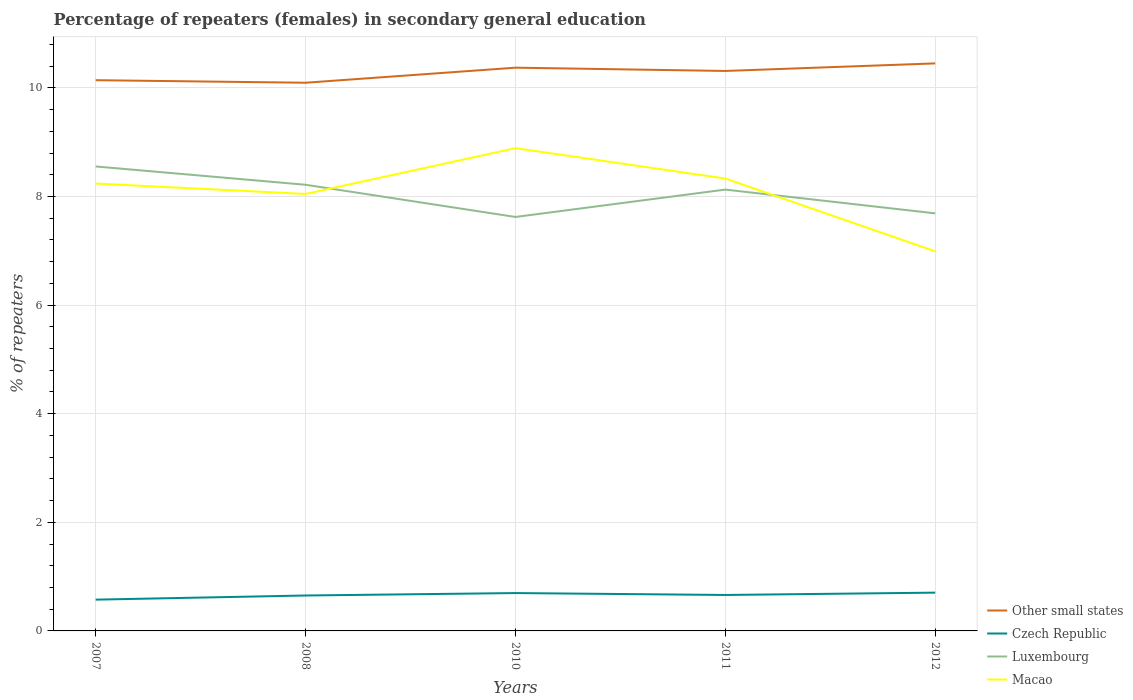Does the line corresponding to Luxembourg intersect with the line corresponding to Macao?
Offer a terse response. Yes. Across all years, what is the maximum percentage of female repeaters in Other small states?
Your answer should be compact. 10.09. In which year was the percentage of female repeaters in Macao maximum?
Keep it short and to the point. 2012. What is the total percentage of female repeaters in Macao in the graph?
Provide a succinct answer. -0.65. What is the difference between the highest and the second highest percentage of female repeaters in Other small states?
Provide a short and direct response. 0.36. What is the difference between the highest and the lowest percentage of female repeaters in Macao?
Your response must be concise. 3. How many lines are there?
Offer a very short reply. 4. How many years are there in the graph?
Your answer should be very brief. 5. Are the values on the major ticks of Y-axis written in scientific E-notation?
Provide a short and direct response. No. Does the graph contain any zero values?
Your answer should be compact. No. What is the title of the graph?
Offer a very short reply. Percentage of repeaters (females) in secondary general education. What is the label or title of the X-axis?
Make the answer very short. Years. What is the label or title of the Y-axis?
Ensure brevity in your answer.  % of repeaters. What is the % of repeaters in Other small states in 2007?
Ensure brevity in your answer.  10.14. What is the % of repeaters of Czech Republic in 2007?
Provide a succinct answer. 0.58. What is the % of repeaters of Luxembourg in 2007?
Offer a terse response. 8.55. What is the % of repeaters in Macao in 2007?
Ensure brevity in your answer.  8.24. What is the % of repeaters of Other small states in 2008?
Your answer should be very brief. 10.09. What is the % of repeaters in Czech Republic in 2008?
Give a very brief answer. 0.65. What is the % of repeaters of Luxembourg in 2008?
Keep it short and to the point. 8.22. What is the % of repeaters in Macao in 2008?
Your answer should be very brief. 8.05. What is the % of repeaters in Other small states in 2010?
Provide a short and direct response. 10.37. What is the % of repeaters of Czech Republic in 2010?
Ensure brevity in your answer.  0.7. What is the % of repeaters of Luxembourg in 2010?
Provide a succinct answer. 7.62. What is the % of repeaters in Macao in 2010?
Your response must be concise. 8.89. What is the % of repeaters of Other small states in 2011?
Your answer should be very brief. 10.31. What is the % of repeaters of Czech Republic in 2011?
Make the answer very short. 0.66. What is the % of repeaters of Luxembourg in 2011?
Provide a succinct answer. 8.13. What is the % of repeaters of Macao in 2011?
Your answer should be very brief. 8.33. What is the % of repeaters of Other small states in 2012?
Provide a succinct answer. 10.45. What is the % of repeaters in Czech Republic in 2012?
Ensure brevity in your answer.  0.7. What is the % of repeaters of Luxembourg in 2012?
Your answer should be very brief. 7.69. What is the % of repeaters of Macao in 2012?
Provide a succinct answer. 6.99. Across all years, what is the maximum % of repeaters in Other small states?
Provide a succinct answer. 10.45. Across all years, what is the maximum % of repeaters of Czech Republic?
Your answer should be compact. 0.7. Across all years, what is the maximum % of repeaters in Luxembourg?
Your answer should be very brief. 8.55. Across all years, what is the maximum % of repeaters of Macao?
Your response must be concise. 8.89. Across all years, what is the minimum % of repeaters of Other small states?
Provide a short and direct response. 10.09. Across all years, what is the minimum % of repeaters of Czech Republic?
Your response must be concise. 0.58. Across all years, what is the minimum % of repeaters of Luxembourg?
Provide a short and direct response. 7.62. Across all years, what is the minimum % of repeaters of Macao?
Your answer should be compact. 6.99. What is the total % of repeaters of Other small states in the graph?
Give a very brief answer. 51.37. What is the total % of repeaters of Czech Republic in the graph?
Your response must be concise. 3.29. What is the total % of repeaters of Luxembourg in the graph?
Ensure brevity in your answer.  40.21. What is the total % of repeaters in Macao in the graph?
Offer a terse response. 40.49. What is the difference between the % of repeaters in Other small states in 2007 and that in 2008?
Offer a very short reply. 0.05. What is the difference between the % of repeaters of Czech Republic in 2007 and that in 2008?
Provide a short and direct response. -0.08. What is the difference between the % of repeaters in Luxembourg in 2007 and that in 2008?
Your answer should be compact. 0.34. What is the difference between the % of repeaters in Macao in 2007 and that in 2008?
Keep it short and to the point. 0.19. What is the difference between the % of repeaters of Other small states in 2007 and that in 2010?
Offer a terse response. -0.23. What is the difference between the % of repeaters in Czech Republic in 2007 and that in 2010?
Your answer should be very brief. -0.12. What is the difference between the % of repeaters of Luxembourg in 2007 and that in 2010?
Keep it short and to the point. 0.93. What is the difference between the % of repeaters in Macao in 2007 and that in 2010?
Offer a terse response. -0.65. What is the difference between the % of repeaters of Other small states in 2007 and that in 2011?
Your response must be concise. -0.17. What is the difference between the % of repeaters of Czech Republic in 2007 and that in 2011?
Offer a very short reply. -0.09. What is the difference between the % of repeaters of Luxembourg in 2007 and that in 2011?
Provide a short and direct response. 0.43. What is the difference between the % of repeaters of Macao in 2007 and that in 2011?
Offer a very short reply. -0.09. What is the difference between the % of repeaters in Other small states in 2007 and that in 2012?
Your answer should be compact. -0.31. What is the difference between the % of repeaters of Czech Republic in 2007 and that in 2012?
Your answer should be compact. -0.13. What is the difference between the % of repeaters in Luxembourg in 2007 and that in 2012?
Provide a succinct answer. 0.86. What is the difference between the % of repeaters of Macao in 2007 and that in 2012?
Provide a succinct answer. 1.25. What is the difference between the % of repeaters of Other small states in 2008 and that in 2010?
Ensure brevity in your answer.  -0.28. What is the difference between the % of repeaters in Czech Republic in 2008 and that in 2010?
Your answer should be very brief. -0.04. What is the difference between the % of repeaters in Luxembourg in 2008 and that in 2010?
Keep it short and to the point. 0.59. What is the difference between the % of repeaters of Macao in 2008 and that in 2010?
Provide a succinct answer. -0.84. What is the difference between the % of repeaters of Other small states in 2008 and that in 2011?
Keep it short and to the point. -0.22. What is the difference between the % of repeaters in Czech Republic in 2008 and that in 2011?
Your answer should be compact. -0.01. What is the difference between the % of repeaters in Luxembourg in 2008 and that in 2011?
Give a very brief answer. 0.09. What is the difference between the % of repeaters of Macao in 2008 and that in 2011?
Provide a short and direct response. -0.28. What is the difference between the % of repeaters of Other small states in 2008 and that in 2012?
Your answer should be very brief. -0.36. What is the difference between the % of repeaters in Czech Republic in 2008 and that in 2012?
Provide a short and direct response. -0.05. What is the difference between the % of repeaters of Luxembourg in 2008 and that in 2012?
Keep it short and to the point. 0.53. What is the difference between the % of repeaters in Macao in 2008 and that in 2012?
Offer a terse response. 1.06. What is the difference between the % of repeaters in Other small states in 2010 and that in 2011?
Offer a very short reply. 0.06. What is the difference between the % of repeaters of Czech Republic in 2010 and that in 2011?
Offer a very short reply. 0.04. What is the difference between the % of repeaters of Luxembourg in 2010 and that in 2011?
Offer a very short reply. -0.5. What is the difference between the % of repeaters in Macao in 2010 and that in 2011?
Your answer should be very brief. 0.56. What is the difference between the % of repeaters of Other small states in 2010 and that in 2012?
Offer a very short reply. -0.08. What is the difference between the % of repeaters of Czech Republic in 2010 and that in 2012?
Provide a succinct answer. -0.01. What is the difference between the % of repeaters in Luxembourg in 2010 and that in 2012?
Give a very brief answer. -0.07. What is the difference between the % of repeaters in Macao in 2010 and that in 2012?
Provide a short and direct response. 1.9. What is the difference between the % of repeaters of Other small states in 2011 and that in 2012?
Provide a short and direct response. -0.14. What is the difference between the % of repeaters of Czech Republic in 2011 and that in 2012?
Your answer should be very brief. -0.04. What is the difference between the % of repeaters of Luxembourg in 2011 and that in 2012?
Your response must be concise. 0.44. What is the difference between the % of repeaters of Macao in 2011 and that in 2012?
Ensure brevity in your answer.  1.34. What is the difference between the % of repeaters in Other small states in 2007 and the % of repeaters in Czech Republic in 2008?
Keep it short and to the point. 9.49. What is the difference between the % of repeaters of Other small states in 2007 and the % of repeaters of Luxembourg in 2008?
Provide a short and direct response. 1.93. What is the difference between the % of repeaters in Other small states in 2007 and the % of repeaters in Macao in 2008?
Provide a short and direct response. 2.09. What is the difference between the % of repeaters of Czech Republic in 2007 and the % of repeaters of Luxembourg in 2008?
Your response must be concise. -7.64. What is the difference between the % of repeaters of Czech Republic in 2007 and the % of repeaters of Macao in 2008?
Offer a terse response. -7.47. What is the difference between the % of repeaters of Luxembourg in 2007 and the % of repeaters of Macao in 2008?
Offer a terse response. 0.51. What is the difference between the % of repeaters of Other small states in 2007 and the % of repeaters of Czech Republic in 2010?
Offer a very short reply. 9.44. What is the difference between the % of repeaters of Other small states in 2007 and the % of repeaters of Luxembourg in 2010?
Provide a short and direct response. 2.52. What is the difference between the % of repeaters in Other small states in 2007 and the % of repeaters in Macao in 2010?
Your answer should be compact. 1.25. What is the difference between the % of repeaters of Czech Republic in 2007 and the % of repeaters of Luxembourg in 2010?
Give a very brief answer. -7.05. What is the difference between the % of repeaters in Czech Republic in 2007 and the % of repeaters in Macao in 2010?
Keep it short and to the point. -8.31. What is the difference between the % of repeaters of Luxembourg in 2007 and the % of repeaters of Macao in 2010?
Provide a succinct answer. -0.34. What is the difference between the % of repeaters of Other small states in 2007 and the % of repeaters of Czech Republic in 2011?
Keep it short and to the point. 9.48. What is the difference between the % of repeaters of Other small states in 2007 and the % of repeaters of Luxembourg in 2011?
Ensure brevity in your answer.  2.01. What is the difference between the % of repeaters of Other small states in 2007 and the % of repeaters of Macao in 2011?
Make the answer very short. 1.81. What is the difference between the % of repeaters of Czech Republic in 2007 and the % of repeaters of Luxembourg in 2011?
Offer a terse response. -7.55. What is the difference between the % of repeaters of Czech Republic in 2007 and the % of repeaters of Macao in 2011?
Your answer should be compact. -7.75. What is the difference between the % of repeaters in Luxembourg in 2007 and the % of repeaters in Macao in 2011?
Keep it short and to the point. 0.22. What is the difference between the % of repeaters in Other small states in 2007 and the % of repeaters in Czech Republic in 2012?
Provide a short and direct response. 9.44. What is the difference between the % of repeaters in Other small states in 2007 and the % of repeaters in Luxembourg in 2012?
Give a very brief answer. 2.45. What is the difference between the % of repeaters of Other small states in 2007 and the % of repeaters of Macao in 2012?
Give a very brief answer. 3.15. What is the difference between the % of repeaters in Czech Republic in 2007 and the % of repeaters in Luxembourg in 2012?
Your response must be concise. -7.11. What is the difference between the % of repeaters of Czech Republic in 2007 and the % of repeaters of Macao in 2012?
Your response must be concise. -6.41. What is the difference between the % of repeaters of Luxembourg in 2007 and the % of repeaters of Macao in 2012?
Ensure brevity in your answer.  1.56. What is the difference between the % of repeaters in Other small states in 2008 and the % of repeaters in Czech Republic in 2010?
Ensure brevity in your answer.  9.4. What is the difference between the % of repeaters in Other small states in 2008 and the % of repeaters in Luxembourg in 2010?
Ensure brevity in your answer.  2.47. What is the difference between the % of repeaters of Other small states in 2008 and the % of repeaters of Macao in 2010?
Keep it short and to the point. 1.2. What is the difference between the % of repeaters in Czech Republic in 2008 and the % of repeaters in Luxembourg in 2010?
Offer a very short reply. -6.97. What is the difference between the % of repeaters of Czech Republic in 2008 and the % of repeaters of Macao in 2010?
Give a very brief answer. -8.24. What is the difference between the % of repeaters in Luxembourg in 2008 and the % of repeaters in Macao in 2010?
Your response must be concise. -0.67. What is the difference between the % of repeaters in Other small states in 2008 and the % of repeaters in Czech Republic in 2011?
Your answer should be very brief. 9.43. What is the difference between the % of repeaters in Other small states in 2008 and the % of repeaters in Luxembourg in 2011?
Provide a succinct answer. 1.97. What is the difference between the % of repeaters in Other small states in 2008 and the % of repeaters in Macao in 2011?
Offer a terse response. 1.76. What is the difference between the % of repeaters of Czech Republic in 2008 and the % of repeaters of Luxembourg in 2011?
Provide a succinct answer. -7.47. What is the difference between the % of repeaters of Czech Republic in 2008 and the % of repeaters of Macao in 2011?
Offer a terse response. -7.68. What is the difference between the % of repeaters in Luxembourg in 2008 and the % of repeaters in Macao in 2011?
Your answer should be very brief. -0.12. What is the difference between the % of repeaters in Other small states in 2008 and the % of repeaters in Czech Republic in 2012?
Make the answer very short. 9.39. What is the difference between the % of repeaters in Other small states in 2008 and the % of repeaters in Luxembourg in 2012?
Keep it short and to the point. 2.41. What is the difference between the % of repeaters of Other small states in 2008 and the % of repeaters of Macao in 2012?
Offer a very short reply. 3.1. What is the difference between the % of repeaters in Czech Republic in 2008 and the % of repeaters in Luxembourg in 2012?
Ensure brevity in your answer.  -7.04. What is the difference between the % of repeaters in Czech Republic in 2008 and the % of repeaters in Macao in 2012?
Make the answer very short. -6.34. What is the difference between the % of repeaters in Luxembourg in 2008 and the % of repeaters in Macao in 2012?
Your answer should be very brief. 1.23. What is the difference between the % of repeaters in Other small states in 2010 and the % of repeaters in Czech Republic in 2011?
Provide a short and direct response. 9.71. What is the difference between the % of repeaters in Other small states in 2010 and the % of repeaters in Luxembourg in 2011?
Keep it short and to the point. 2.24. What is the difference between the % of repeaters of Other small states in 2010 and the % of repeaters of Macao in 2011?
Your answer should be compact. 2.04. What is the difference between the % of repeaters in Czech Republic in 2010 and the % of repeaters in Luxembourg in 2011?
Offer a very short reply. -7.43. What is the difference between the % of repeaters of Czech Republic in 2010 and the % of repeaters of Macao in 2011?
Keep it short and to the point. -7.63. What is the difference between the % of repeaters in Luxembourg in 2010 and the % of repeaters in Macao in 2011?
Give a very brief answer. -0.71. What is the difference between the % of repeaters of Other small states in 2010 and the % of repeaters of Czech Republic in 2012?
Give a very brief answer. 9.67. What is the difference between the % of repeaters in Other small states in 2010 and the % of repeaters in Luxembourg in 2012?
Offer a very short reply. 2.68. What is the difference between the % of repeaters in Other small states in 2010 and the % of repeaters in Macao in 2012?
Make the answer very short. 3.38. What is the difference between the % of repeaters of Czech Republic in 2010 and the % of repeaters of Luxembourg in 2012?
Your answer should be very brief. -6.99. What is the difference between the % of repeaters in Czech Republic in 2010 and the % of repeaters in Macao in 2012?
Provide a succinct answer. -6.29. What is the difference between the % of repeaters of Luxembourg in 2010 and the % of repeaters of Macao in 2012?
Offer a terse response. 0.63. What is the difference between the % of repeaters in Other small states in 2011 and the % of repeaters in Czech Republic in 2012?
Provide a succinct answer. 9.61. What is the difference between the % of repeaters in Other small states in 2011 and the % of repeaters in Luxembourg in 2012?
Your answer should be compact. 2.62. What is the difference between the % of repeaters of Other small states in 2011 and the % of repeaters of Macao in 2012?
Provide a short and direct response. 3.32. What is the difference between the % of repeaters in Czech Republic in 2011 and the % of repeaters in Luxembourg in 2012?
Make the answer very short. -7.03. What is the difference between the % of repeaters of Czech Republic in 2011 and the % of repeaters of Macao in 2012?
Give a very brief answer. -6.33. What is the difference between the % of repeaters of Luxembourg in 2011 and the % of repeaters of Macao in 2012?
Your answer should be compact. 1.14. What is the average % of repeaters of Other small states per year?
Offer a terse response. 10.27. What is the average % of repeaters in Czech Republic per year?
Your answer should be very brief. 0.66. What is the average % of repeaters in Luxembourg per year?
Your answer should be very brief. 8.04. What is the average % of repeaters of Macao per year?
Your response must be concise. 8.1. In the year 2007, what is the difference between the % of repeaters of Other small states and % of repeaters of Czech Republic?
Give a very brief answer. 9.56. In the year 2007, what is the difference between the % of repeaters in Other small states and % of repeaters in Luxembourg?
Offer a terse response. 1.59. In the year 2007, what is the difference between the % of repeaters in Other small states and % of repeaters in Macao?
Your response must be concise. 1.9. In the year 2007, what is the difference between the % of repeaters of Czech Republic and % of repeaters of Luxembourg?
Ensure brevity in your answer.  -7.98. In the year 2007, what is the difference between the % of repeaters of Czech Republic and % of repeaters of Macao?
Provide a short and direct response. -7.66. In the year 2007, what is the difference between the % of repeaters of Luxembourg and % of repeaters of Macao?
Give a very brief answer. 0.31. In the year 2008, what is the difference between the % of repeaters in Other small states and % of repeaters in Czech Republic?
Give a very brief answer. 9.44. In the year 2008, what is the difference between the % of repeaters of Other small states and % of repeaters of Luxembourg?
Your answer should be very brief. 1.88. In the year 2008, what is the difference between the % of repeaters of Other small states and % of repeaters of Macao?
Your answer should be very brief. 2.05. In the year 2008, what is the difference between the % of repeaters in Czech Republic and % of repeaters in Luxembourg?
Your response must be concise. -7.56. In the year 2008, what is the difference between the % of repeaters of Czech Republic and % of repeaters of Macao?
Give a very brief answer. -7.39. In the year 2008, what is the difference between the % of repeaters in Luxembourg and % of repeaters in Macao?
Offer a very short reply. 0.17. In the year 2010, what is the difference between the % of repeaters in Other small states and % of repeaters in Czech Republic?
Keep it short and to the point. 9.67. In the year 2010, what is the difference between the % of repeaters in Other small states and % of repeaters in Luxembourg?
Offer a very short reply. 2.75. In the year 2010, what is the difference between the % of repeaters of Other small states and % of repeaters of Macao?
Your response must be concise. 1.48. In the year 2010, what is the difference between the % of repeaters in Czech Republic and % of repeaters in Luxembourg?
Your answer should be compact. -6.93. In the year 2010, what is the difference between the % of repeaters of Czech Republic and % of repeaters of Macao?
Provide a short and direct response. -8.19. In the year 2010, what is the difference between the % of repeaters in Luxembourg and % of repeaters in Macao?
Offer a very short reply. -1.27. In the year 2011, what is the difference between the % of repeaters of Other small states and % of repeaters of Czech Republic?
Give a very brief answer. 9.65. In the year 2011, what is the difference between the % of repeaters of Other small states and % of repeaters of Luxembourg?
Keep it short and to the point. 2.18. In the year 2011, what is the difference between the % of repeaters in Other small states and % of repeaters in Macao?
Keep it short and to the point. 1.98. In the year 2011, what is the difference between the % of repeaters of Czech Republic and % of repeaters of Luxembourg?
Provide a short and direct response. -7.46. In the year 2011, what is the difference between the % of repeaters in Czech Republic and % of repeaters in Macao?
Make the answer very short. -7.67. In the year 2011, what is the difference between the % of repeaters in Luxembourg and % of repeaters in Macao?
Offer a terse response. -0.2. In the year 2012, what is the difference between the % of repeaters in Other small states and % of repeaters in Czech Republic?
Your answer should be compact. 9.75. In the year 2012, what is the difference between the % of repeaters of Other small states and % of repeaters of Luxembourg?
Make the answer very short. 2.76. In the year 2012, what is the difference between the % of repeaters of Other small states and % of repeaters of Macao?
Your response must be concise. 3.46. In the year 2012, what is the difference between the % of repeaters in Czech Republic and % of repeaters in Luxembourg?
Make the answer very short. -6.98. In the year 2012, what is the difference between the % of repeaters in Czech Republic and % of repeaters in Macao?
Ensure brevity in your answer.  -6.28. In the year 2012, what is the difference between the % of repeaters in Luxembourg and % of repeaters in Macao?
Provide a short and direct response. 0.7. What is the ratio of the % of repeaters of Czech Republic in 2007 to that in 2008?
Ensure brevity in your answer.  0.88. What is the ratio of the % of repeaters in Luxembourg in 2007 to that in 2008?
Keep it short and to the point. 1.04. What is the ratio of the % of repeaters in Macao in 2007 to that in 2008?
Ensure brevity in your answer.  1.02. What is the ratio of the % of repeaters of Other small states in 2007 to that in 2010?
Offer a very short reply. 0.98. What is the ratio of the % of repeaters in Czech Republic in 2007 to that in 2010?
Your response must be concise. 0.83. What is the ratio of the % of repeaters in Luxembourg in 2007 to that in 2010?
Offer a very short reply. 1.12. What is the ratio of the % of repeaters in Macao in 2007 to that in 2010?
Offer a very short reply. 0.93. What is the ratio of the % of repeaters of Other small states in 2007 to that in 2011?
Offer a very short reply. 0.98. What is the ratio of the % of repeaters in Czech Republic in 2007 to that in 2011?
Keep it short and to the point. 0.87. What is the ratio of the % of repeaters of Luxembourg in 2007 to that in 2011?
Offer a terse response. 1.05. What is the ratio of the % of repeaters in Macao in 2007 to that in 2011?
Offer a terse response. 0.99. What is the ratio of the % of repeaters in Other small states in 2007 to that in 2012?
Give a very brief answer. 0.97. What is the ratio of the % of repeaters in Czech Republic in 2007 to that in 2012?
Make the answer very short. 0.82. What is the ratio of the % of repeaters of Luxembourg in 2007 to that in 2012?
Give a very brief answer. 1.11. What is the ratio of the % of repeaters of Macao in 2007 to that in 2012?
Provide a short and direct response. 1.18. What is the ratio of the % of repeaters in Other small states in 2008 to that in 2010?
Make the answer very short. 0.97. What is the ratio of the % of repeaters in Czech Republic in 2008 to that in 2010?
Ensure brevity in your answer.  0.94. What is the ratio of the % of repeaters of Luxembourg in 2008 to that in 2010?
Your answer should be very brief. 1.08. What is the ratio of the % of repeaters in Macao in 2008 to that in 2010?
Your answer should be compact. 0.91. What is the ratio of the % of repeaters of Other small states in 2008 to that in 2011?
Offer a terse response. 0.98. What is the ratio of the % of repeaters in Czech Republic in 2008 to that in 2011?
Make the answer very short. 0.99. What is the ratio of the % of repeaters in Luxembourg in 2008 to that in 2011?
Your response must be concise. 1.01. What is the ratio of the % of repeaters of Macao in 2008 to that in 2011?
Make the answer very short. 0.97. What is the ratio of the % of repeaters in Other small states in 2008 to that in 2012?
Ensure brevity in your answer.  0.97. What is the ratio of the % of repeaters of Czech Republic in 2008 to that in 2012?
Keep it short and to the point. 0.93. What is the ratio of the % of repeaters in Luxembourg in 2008 to that in 2012?
Offer a terse response. 1.07. What is the ratio of the % of repeaters in Macao in 2008 to that in 2012?
Give a very brief answer. 1.15. What is the ratio of the % of repeaters in Other small states in 2010 to that in 2011?
Your answer should be very brief. 1.01. What is the ratio of the % of repeaters of Czech Republic in 2010 to that in 2011?
Give a very brief answer. 1.05. What is the ratio of the % of repeaters in Luxembourg in 2010 to that in 2011?
Make the answer very short. 0.94. What is the ratio of the % of repeaters in Macao in 2010 to that in 2011?
Offer a very short reply. 1.07. What is the ratio of the % of repeaters of Macao in 2010 to that in 2012?
Give a very brief answer. 1.27. What is the ratio of the % of repeaters of Other small states in 2011 to that in 2012?
Make the answer very short. 0.99. What is the ratio of the % of repeaters in Czech Republic in 2011 to that in 2012?
Your answer should be very brief. 0.94. What is the ratio of the % of repeaters of Luxembourg in 2011 to that in 2012?
Ensure brevity in your answer.  1.06. What is the ratio of the % of repeaters of Macao in 2011 to that in 2012?
Keep it short and to the point. 1.19. What is the difference between the highest and the second highest % of repeaters in Other small states?
Provide a short and direct response. 0.08. What is the difference between the highest and the second highest % of repeaters of Czech Republic?
Provide a short and direct response. 0.01. What is the difference between the highest and the second highest % of repeaters of Luxembourg?
Ensure brevity in your answer.  0.34. What is the difference between the highest and the second highest % of repeaters of Macao?
Offer a terse response. 0.56. What is the difference between the highest and the lowest % of repeaters in Other small states?
Keep it short and to the point. 0.36. What is the difference between the highest and the lowest % of repeaters in Czech Republic?
Your answer should be compact. 0.13. What is the difference between the highest and the lowest % of repeaters in Luxembourg?
Make the answer very short. 0.93. What is the difference between the highest and the lowest % of repeaters in Macao?
Your answer should be very brief. 1.9. 